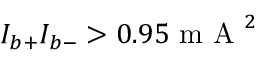Convert formula to latex. <formula><loc_0><loc_0><loc_500><loc_500>I _ { b + } I _ { b - } > 0 . 9 5 m A ^ { 2 }</formula> 